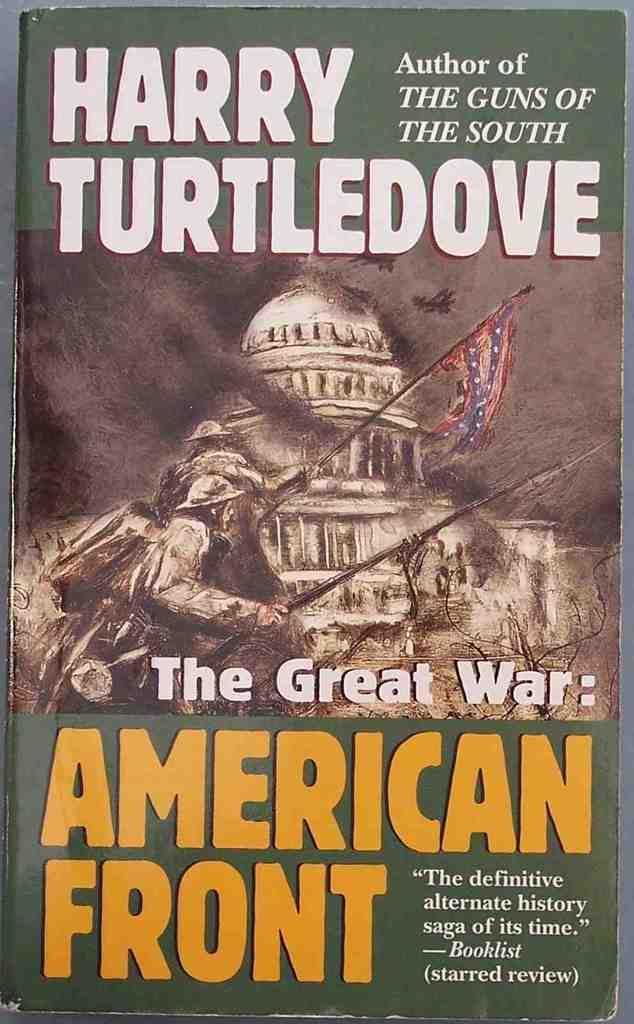<image>
Share a concise interpretation of the image provided. book named the great war: american front that has picture of confederate soldiers in front of the capitol 